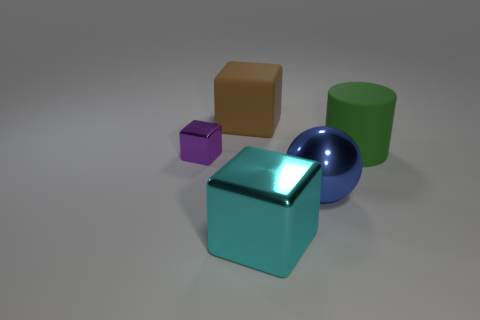Could you describe the sizes of the objects relative to each other? Certainly! Relative to each other, the blue ball is the smallest object, followed by the purple cube. The brown cube is larger than these two, and the green cylinder is about the same height as the turquoise block but wider. The turquoise block itself is the largest object in terms of both height and width. 